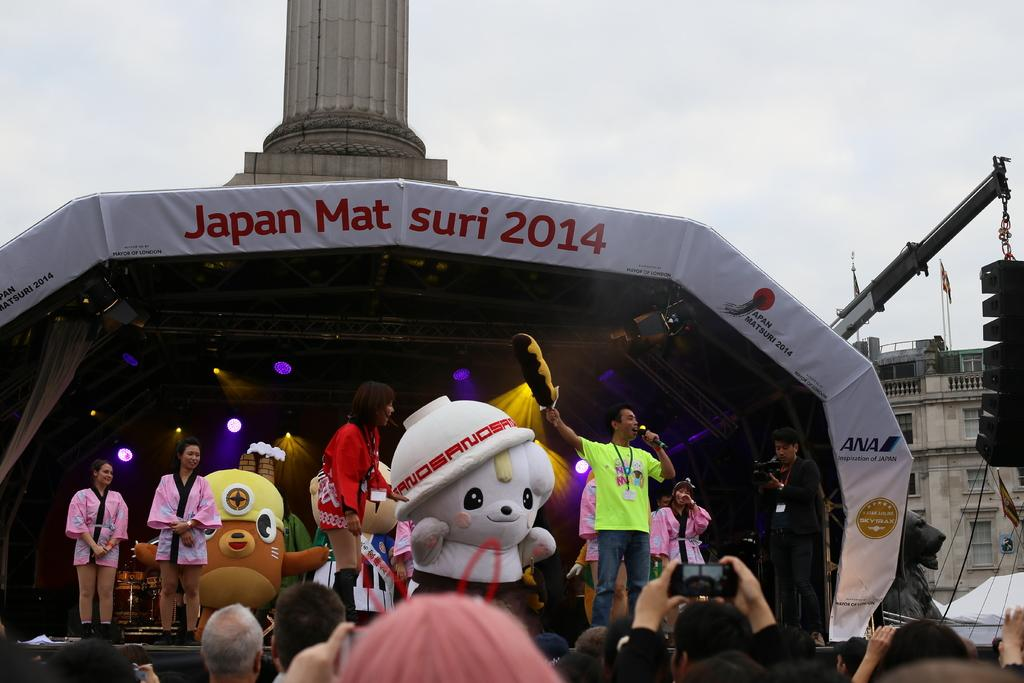How many people are in the image? There is a group of people in the image. What other objects or figures can be seen in the image? There are doll statues, a mobile phone, and a banner in the image. What type of structures are visible in the image? There are buildings in the image. What is visible at the top of the image? The sky is visible at the top of the image. How many coughs can be heard in the image? There is no sound present in the image, so it is not possible to determine the number of coughs. 